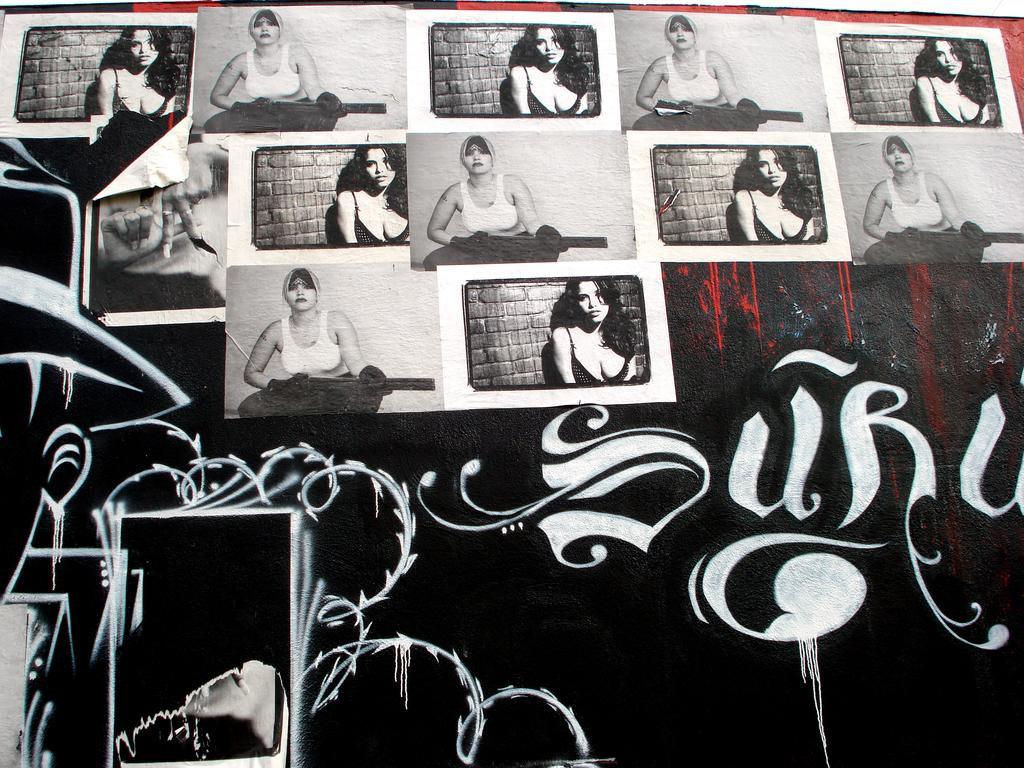What is the main subject in the center of the image? There is a wall in the center of the image. What is depicted on the wall? There is graffiti on the wall. Are there any other items or decorations on the wall? Yes, photos are placed on the wall. What invention is being demonstrated in the graffiti on the wall? There is no invention being demonstrated in the graffiti on the wall; it is simply an artistic expression. 